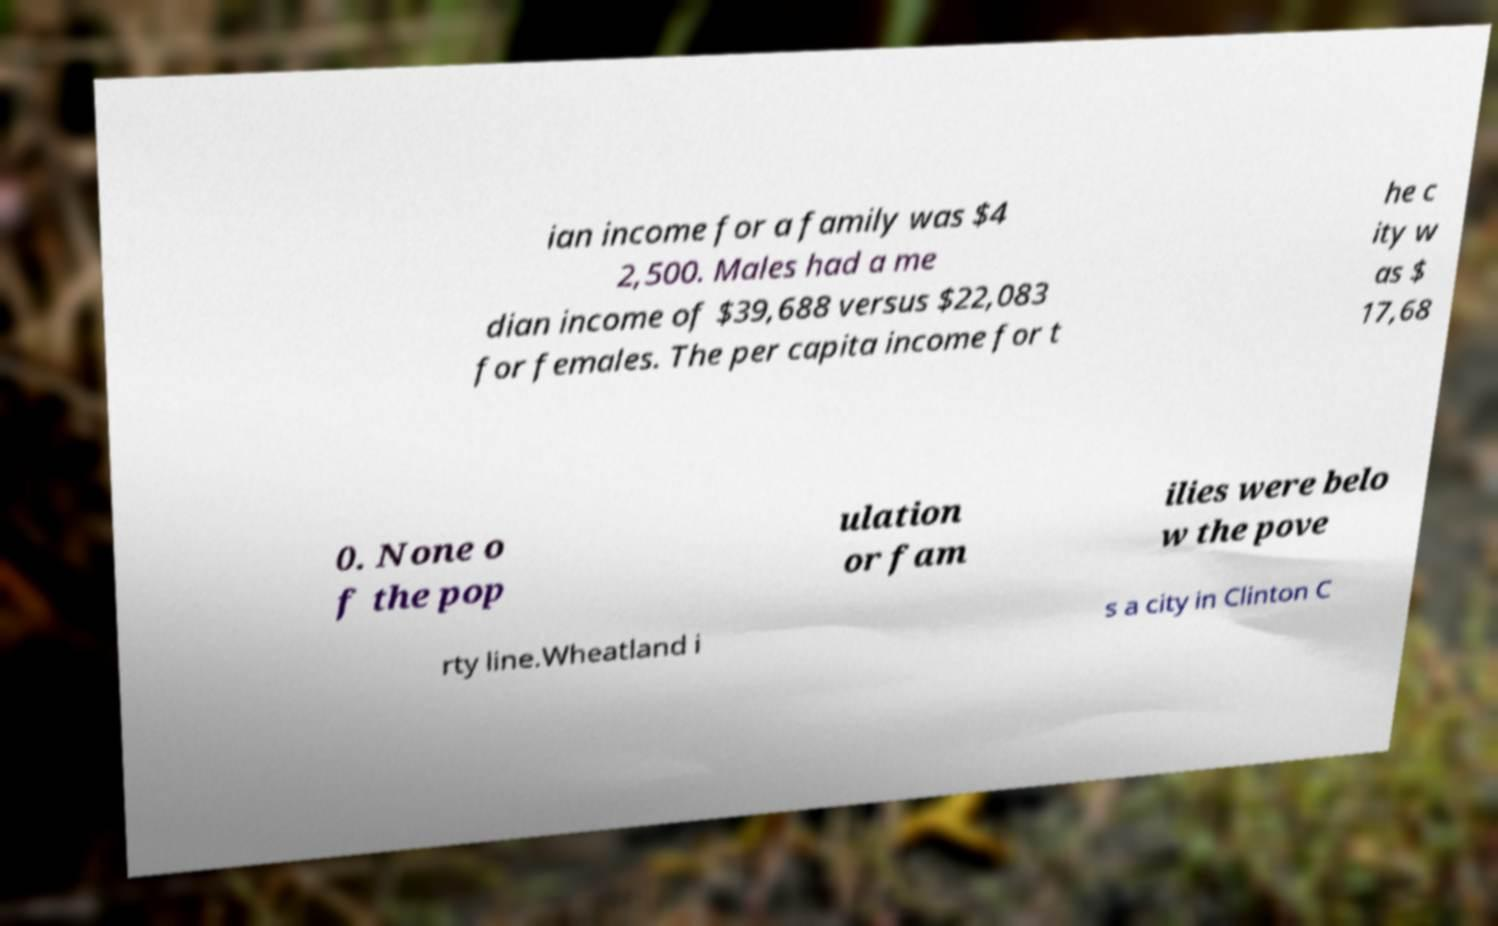Please read and relay the text visible in this image. What does it say? ian income for a family was $4 2,500. Males had a me dian income of $39,688 versus $22,083 for females. The per capita income for t he c ity w as $ 17,68 0. None o f the pop ulation or fam ilies were belo w the pove rty line.Wheatland i s a city in Clinton C 